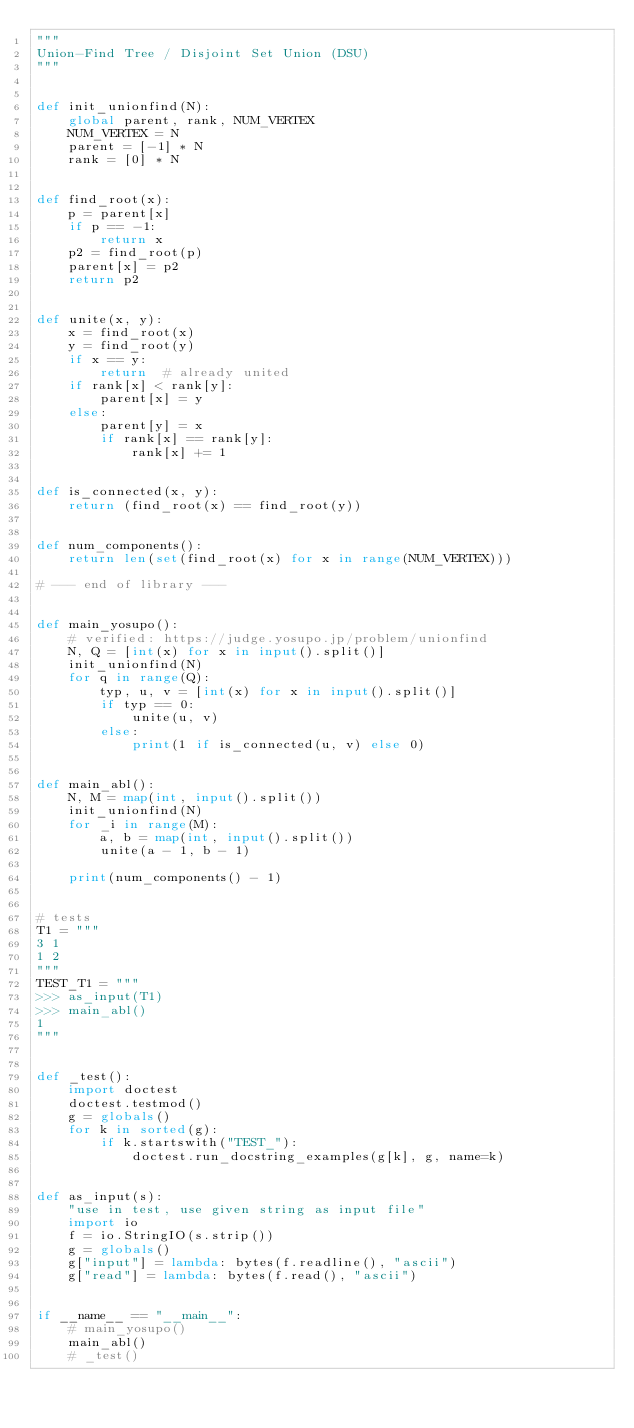<code> <loc_0><loc_0><loc_500><loc_500><_Python_>"""
Union-Find Tree / Disjoint Set Union (DSU)
"""


def init_unionfind(N):
    global parent, rank, NUM_VERTEX
    NUM_VERTEX = N
    parent = [-1] * N
    rank = [0] * N


def find_root(x):
    p = parent[x]
    if p == -1:
        return x
    p2 = find_root(p)
    parent[x] = p2
    return p2


def unite(x, y):
    x = find_root(x)
    y = find_root(y)
    if x == y:
        return  # already united
    if rank[x] < rank[y]:
        parent[x] = y
    else:
        parent[y] = x
        if rank[x] == rank[y]:
            rank[x] += 1


def is_connected(x, y):
    return (find_root(x) == find_root(y))


def num_components():
    return len(set(find_root(x) for x in range(NUM_VERTEX)))

# --- end of library ---


def main_yosupo():
    # verified: https://judge.yosupo.jp/problem/unionfind
    N, Q = [int(x) for x in input().split()]
    init_unionfind(N)
    for q in range(Q):
        typ, u, v = [int(x) for x in input().split()]
        if typ == 0:
            unite(u, v)
        else:
            print(1 if is_connected(u, v) else 0)


def main_abl():
    N, M = map(int, input().split())
    init_unionfind(N)
    for _i in range(M):
        a, b = map(int, input().split())
        unite(a - 1, b - 1)

    print(num_components() - 1)


# tests
T1 = """
3 1
1 2
"""
TEST_T1 = """
>>> as_input(T1)
>>> main_abl()
1
"""


def _test():
    import doctest
    doctest.testmod()
    g = globals()
    for k in sorted(g):
        if k.startswith("TEST_"):
            doctest.run_docstring_examples(g[k], g, name=k)


def as_input(s):
    "use in test, use given string as input file"
    import io
    f = io.StringIO(s.strip())
    g = globals()
    g["input"] = lambda: bytes(f.readline(), "ascii")
    g["read"] = lambda: bytes(f.read(), "ascii")


if __name__ == "__main__":
    # main_yosupo()
    main_abl()
    # _test()
</code> 